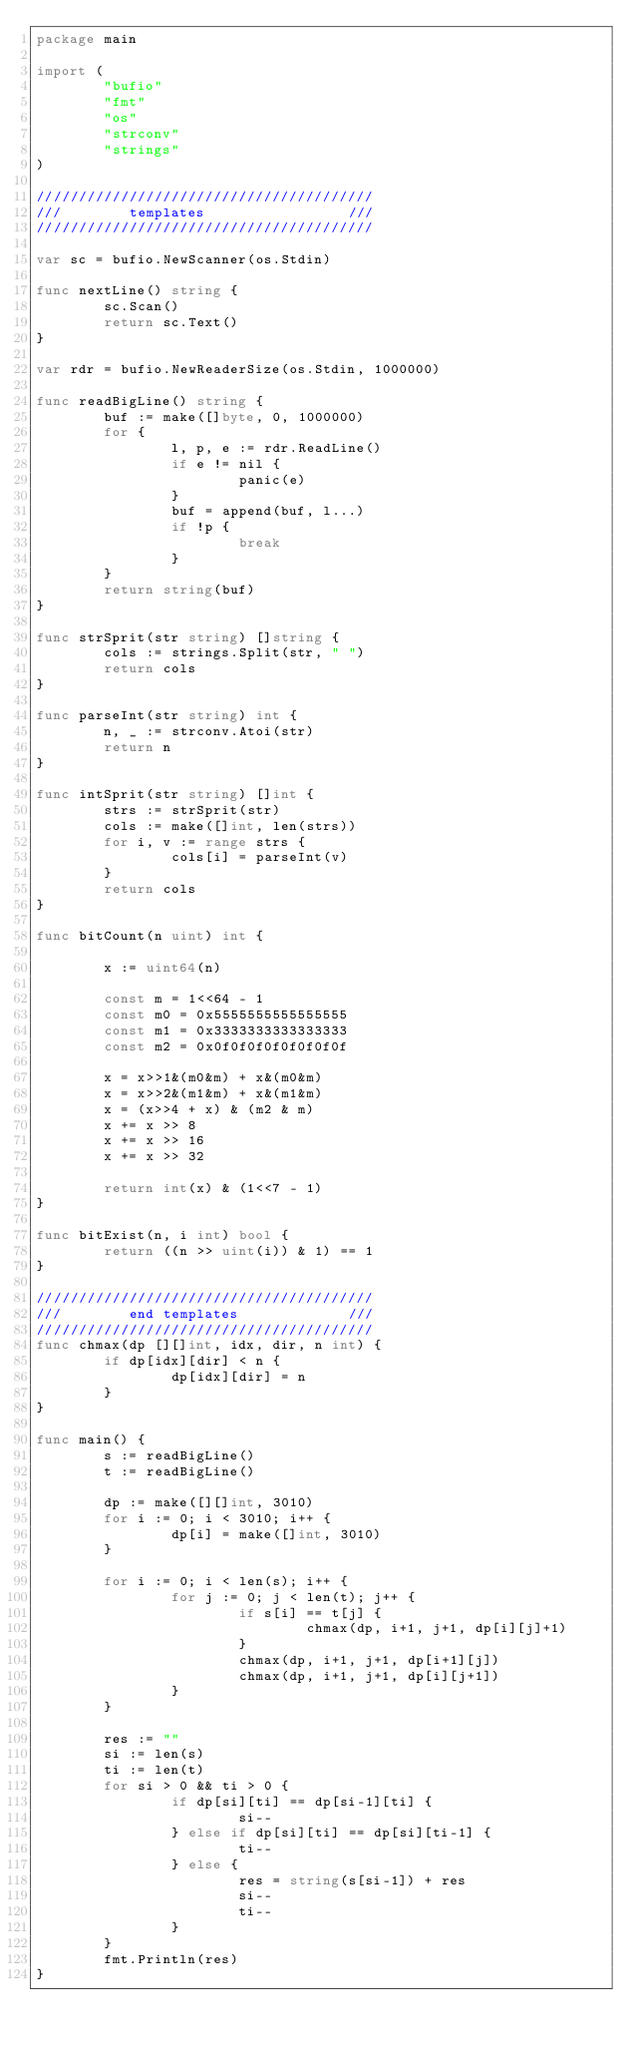<code> <loc_0><loc_0><loc_500><loc_500><_Go_>package main

import (
        "bufio"
        "fmt"
        "os"
        "strconv"
        "strings"
)

////////////////////////////////////////
///        templates                 ///
////////////////////////////////////////

var sc = bufio.NewScanner(os.Stdin)

func nextLine() string {
        sc.Scan()
        return sc.Text()
}

var rdr = bufio.NewReaderSize(os.Stdin, 1000000)

func readBigLine() string {
        buf := make([]byte, 0, 1000000)
        for {
                l, p, e := rdr.ReadLine()
                if e != nil {
                        panic(e)
                }
                buf = append(buf, l...)
                if !p {
                        break
                }
        }
        return string(buf)
}

func strSprit(str string) []string {
        cols := strings.Split(str, " ")
        return cols
}

func parseInt(str string) int {
        n, _ := strconv.Atoi(str)
        return n
}

func intSprit(str string) []int {
        strs := strSprit(str)
        cols := make([]int, len(strs))
        for i, v := range strs {
                cols[i] = parseInt(v)
        }
        return cols
}

func bitCount(n uint) int {

        x := uint64(n)

        const m = 1<<64 - 1
        const m0 = 0x5555555555555555
        const m1 = 0x3333333333333333
        const m2 = 0x0f0f0f0f0f0f0f0f

        x = x>>1&(m0&m) + x&(m0&m)
        x = x>>2&(m1&m) + x&(m1&m)
        x = (x>>4 + x) & (m2 & m)
        x += x >> 8
        x += x >> 16
        x += x >> 32

        return int(x) & (1<<7 - 1)
}

func bitExist(n, i int) bool {
        return ((n >> uint(i)) & 1) == 1
}

////////////////////////////////////////
///        end templates             ///
////////////////////////////////////////
func chmax(dp [][]int, idx, dir, n int) {
        if dp[idx][dir] < n {
                dp[idx][dir] = n
        }
}

func main() {
        s := readBigLine()
        t := readBigLine()

        dp := make([][]int, 3010)
        for i := 0; i < 3010; i++ {
                dp[i] = make([]int, 3010)
        }

        for i := 0; i < len(s); i++ {
                for j := 0; j < len(t); j++ {
                        if s[i] == t[j] {
                                chmax(dp, i+1, j+1, dp[i][j]+1)
                        }
                        chmax(dp, i+1, j+1, dp[i+1][j])
                        chmax(dp, i+1, j+1, dp[i][j+1])
                }
        }

        res := ""
        si := len(s)
        ti := len(t)
        for si > 0 && ti > 0 {
                if dp[si][ti] == dp[si-1][ti] {
                        si--
                } else if dp[si][ti] == dp[si][ti-1] {
                        ti--
                } else {
                        res = string(s[si-1]) + res
                        si--
                        ti--
                }
        }
        fmt.Println(res)
}</code> 